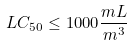Convert formula to latex. <formula><loc_0><loc_0><loc_500><loc_500>L C _ { 5 0 } \leq 1 0 0 0 \frac { m L } { m ^ { 3 } }</formula> 